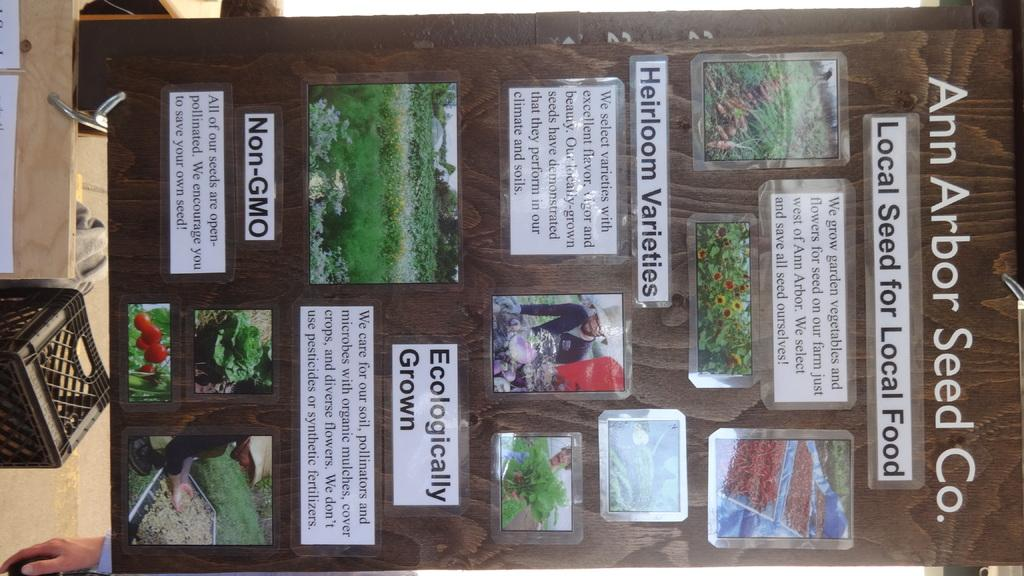<image>
Create a compact narrative representing the image presented. A large piece of wood has photos of gardens and says Ann Arbor Seed Co. 